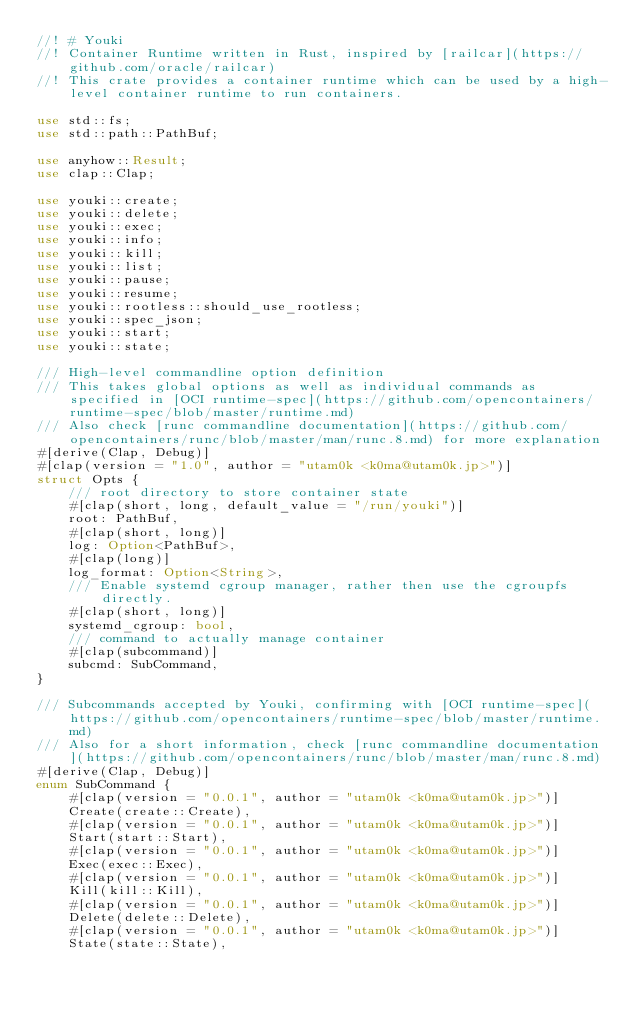<code> <loc_0><loc_0><loc_500><loc_500><_Rust_>//! # Youki
//! Container Runtime written in Rust, inspired by [railcar](https://github.com/oracle/railcar)
//! This crate provides a container runtime which can be used by a high-level container runtime to run containers.

use std::fs;
use std::path::PathBuf;

use anyhow::Result;
use clap::Clap;

use youki::create;
use youki::delete;
use youki::exec;
use youki::info;
use youki::kill;
use youki::list;
use youki::pause;
use youki::resume;
use youki::rootless::should_use_rootless;
use youki::spec_json;
use youki::start;
use youki::state;

/// High-level commandline option definition
/// This takes global options as well as individual commands as specified in [OCI runtime-spec](https://github.com/opencontainers/runtime-spec/blob/master/runtime.md)
/// Also check [runc commandline documentation](https://github.com/opencontainers/runc/blob/master/man/runc.8.md) for more explanation
#[derive(Clap, Debug)]
#[clap(version = "1.0", author = "utam0k <k0ma@utam0k.jp>")]
struct Opts {
    /// root directory to store container state
    #[clap(short, long, default_value = "/run/youki")]
    root: PathBuf,
    #[clap(short, long)]
    log: Option<PathBuf>,
    #[clap(long)]
    log_format: Option<String>,
    /// Enable systemd cgroup manager, rather then use the cgroupfs directly.
    #[clap(short, long)]
    systemd_cgroup: bool,
    /// command to actually manage container
    #[clap(subcommand)]
    subcmd: SubCommand,
}

/// Subcommands accepted by Youki, confirming with [OCI runtime-spec](https://github.com/opencontainers/runtime-spec/blob/master/runtime.md)
/// Also for a short information, check [runc commandline documentation](https://github.com/opencontainers/runc/blob/master/man/runc.8.md)
#[derive(Clap, Debug)]
enum SubCommand {
    #[clap(version = "0.0.1", author = "utam0k <k0ma@utam0k.jp>")]
    Create(create::Create),
    #[clap(version = "0.0.1", author = "utam0k <k0ma@utam0k.jp>")]
    Start(start::Start),
    #[clap(version = "0.0.1", author = "utam0k <k0ma@utam0k.jp>")]
    Exec(exec::Exec),
    #[clap(version = "0.0.1", author = "utam0k <k0ma@utam0k.jp>")]
    Kill(kill::Kill),
    #[clap(version = "0.0.1", author = "utam0k <k0ma@utam0k.jp>")]
    Delete(delete::Delete),
    #[clap(version = "0.0.1", author = "utam0k <k0ma@utam0k.jp>")]
    State(state::State),</code> 